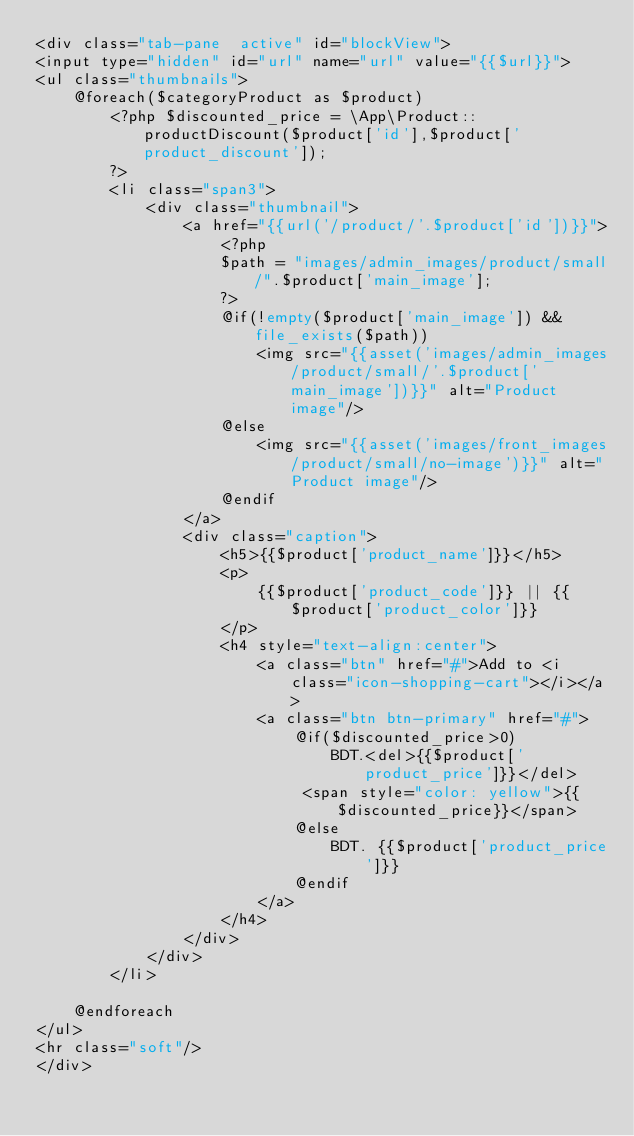Convert code to text. <code><loc_0><loc_0><loc_500><loc_500><_PHP_><div class="tab-pane  active" id="blockView">
<input type="hidden" id="url" name="url" value="{{$url}}">
<ul class="thumbnails">
    @foreach($categoryProduct as $product)
        <?php $discounted_price = \App\Product::productDiscount($product['id'],$product['product_discount']);
        ?>
        <li class="span3">
            <div class="thumbnail">
                <a href="{{url('/product/'.$product['id'])}}">
                    <?php
                    $path = "images/admin_images/product/small/".$product['main_image'];
                    ?>
                    @if(!empty($product['main_image']) && file_exists($path))
                        <img src="{{asset('images/admin_images/product/small/'.$product['main_image'])}}" alt="Product image"/>
                    @else
                        <img src="{{asset('images/front_images/product/small/no-image')}}" alt="Product image"/>
                    @endif
                </a>
                <div class="caption">
                    <h5>{{$product['product_name']}}</h5>
                    <p>
                        {{$product['product_code']}} || {{$product['product_color']}}
                    </p>
                    <h4 style="text-align:center">
                        <a class="btn" href="#">Add to <i class="icon-shopping-cart"></i></a>
                        <a class="btn btn-primary" href="#">
                            @if($discounted_price>0)
                                BDT.<del>{{$product['product_price']}}</del>
                             <span style="color: yellow">{{$discounted_price}}</span>
                            @else
                                BDT. {{$product['product_price']}}
                            @endif
                        </a>
                    </h4>
                </div>
            </div>
        </li>

    @endforeach
</ul>
<hr class="soft"/>
</div></code> 